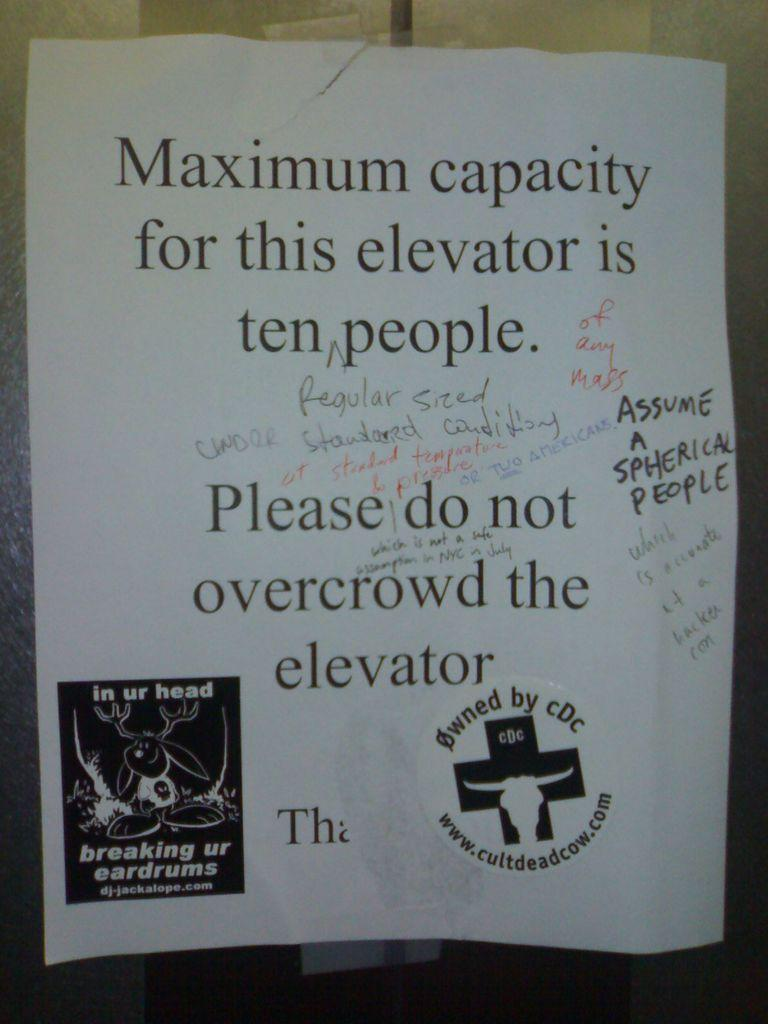<image>
Provide a brief description of the given image. a paper talking about overcrowding on an elevator 